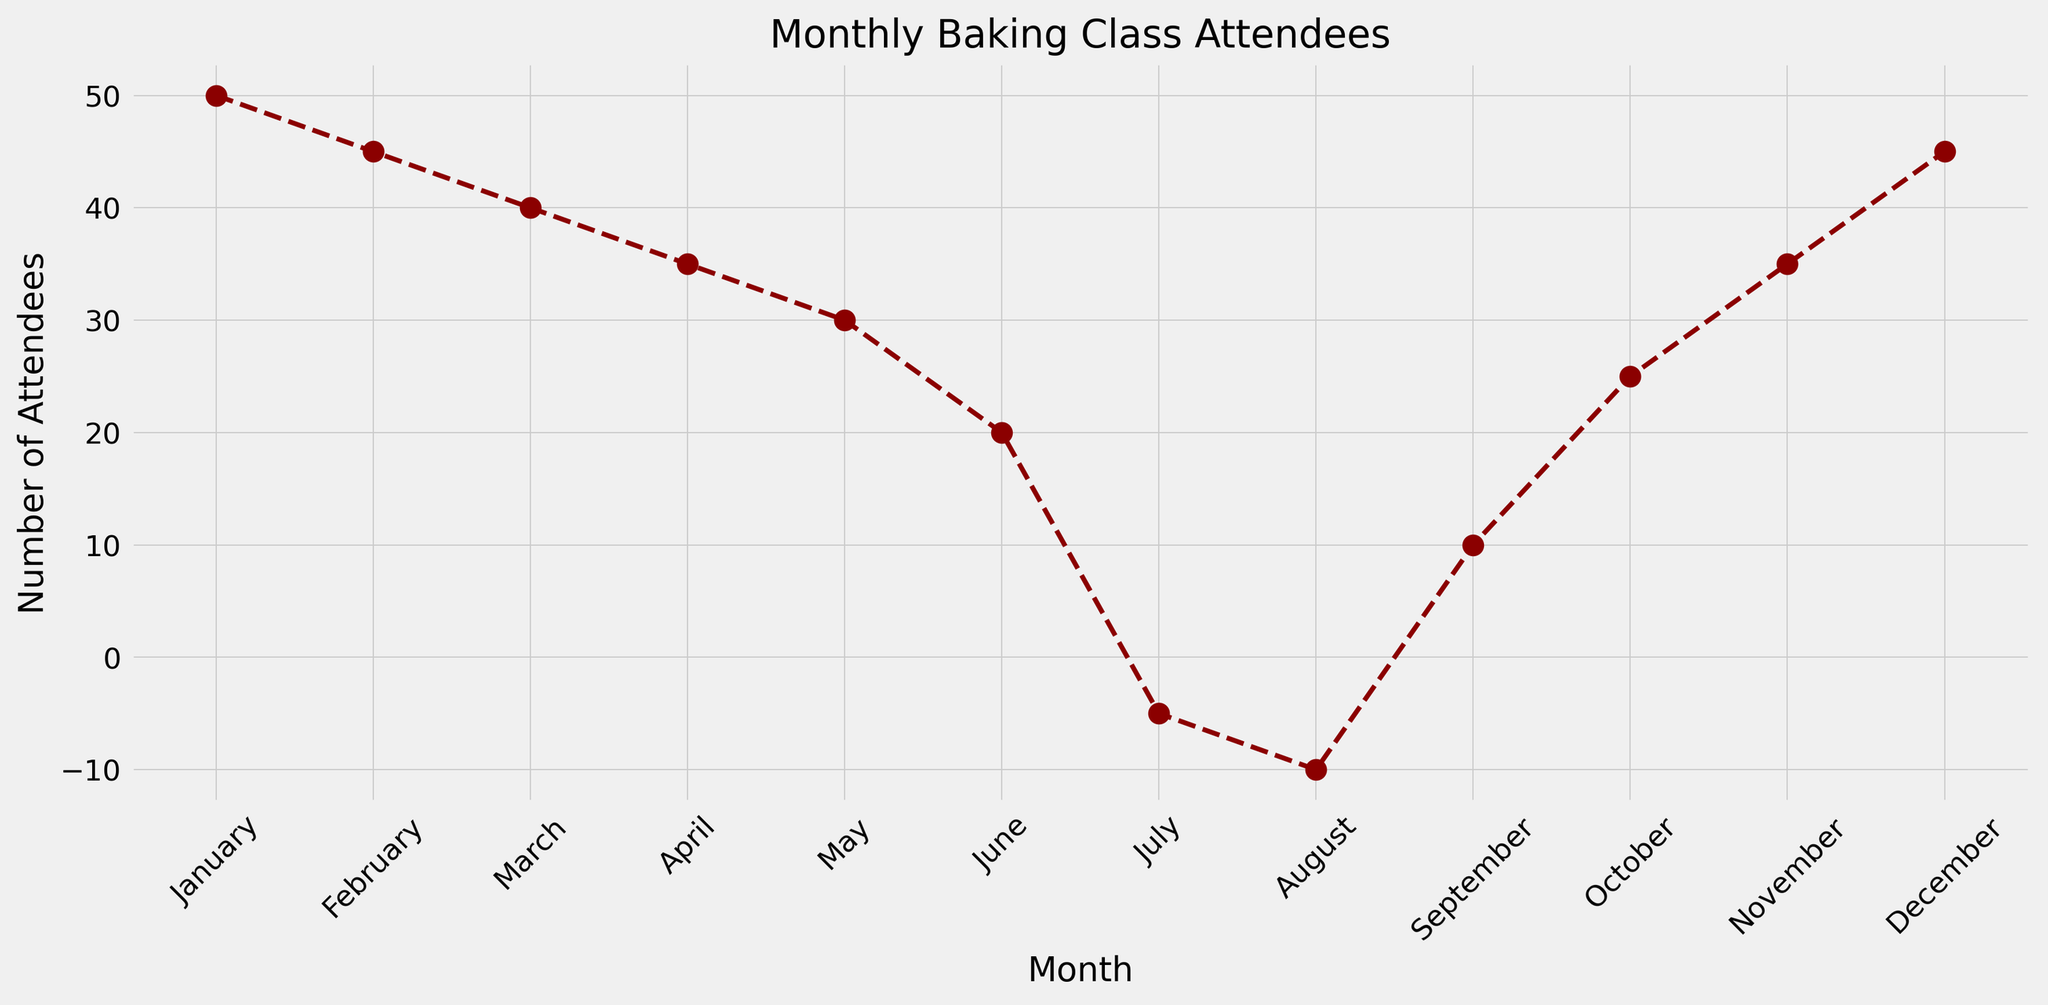what trend does the line chart show for the number of attendees from January to December? The chart starts with higher attendance in January at 50, which gradually decreases to a low point in July and August with negative values. Participation starts to recover in September, steadily climbing back up to 45 attendees by December.
Answer: Decrease, then increase Which months show negative values for the number of attendees? Observing the y-axis and the points plotted on the line chart, only July and August show negative values.
Answer: July and August What is the difference in the number of attendees between January and June? The number of attendees in January is 50, while in June it is 20. The difference is calculated as 50 - 20.
Answer: 30 In which month does the number of attendees reach its lowest point? The month with the lowest point on the y-axis, represented by the lowest plotted point on the chart, is August.
Answer: August What is the combined total number of attendees for January, February, and March? Sum the attendees for January (50), February (45), and March (40): 50 + 45 + 40 = 135.
Answer: 135 How does the number of attendees in October compare to that in May? The number of attendees in October is 25, and in May, it is 30. Comparing these values, attendees in October are fewer than in May.
Answer: Fewer What is the range of the number of attendees throughout the year? The range is calculated by subtracting the lowest value (August: -10) from the highest value (January: 50).
Answer: 60 What is the average number of attendees from January to December? Add all monthly attendees: 50 + 45 + 40 + 35 + 30 + 20 - 5 - 10 + 10 + 25 + 35 + 45 and divide by 12. The sum is 320, so 320/12 ≈ 26.67.
Answer: 26.67 Between which consecutive months is the steepest decline in attendees observed? Checking the chart for the steepest slope downwards, the steepest decline happens from June (20) to July (-5).
Answer: June to July What is the median number of attendees over the year? Ordering the values: -10, -5, 10, 20, 25, 30, 35, 35, 40, 45, 45, 50. With 12 values, the median is the average of the 6th and 7th: (30+35)/2 = 32.5.
Answer: 32.5 